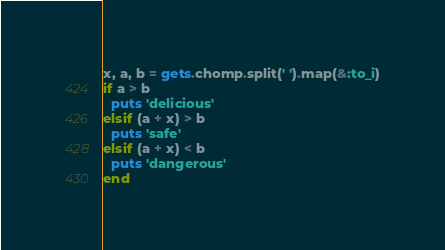<code> <loc_0><loc_0><loc_500><loc_500><_Ruby_>x, a, b = gets.chomp.split(' ').map(&:to_i)
if a > b
  puts 'delicious'
elsif (a + x) > b
  puts 'safe'
elsif (a + x) < b
  puts 'dangerous'
end
</code> 